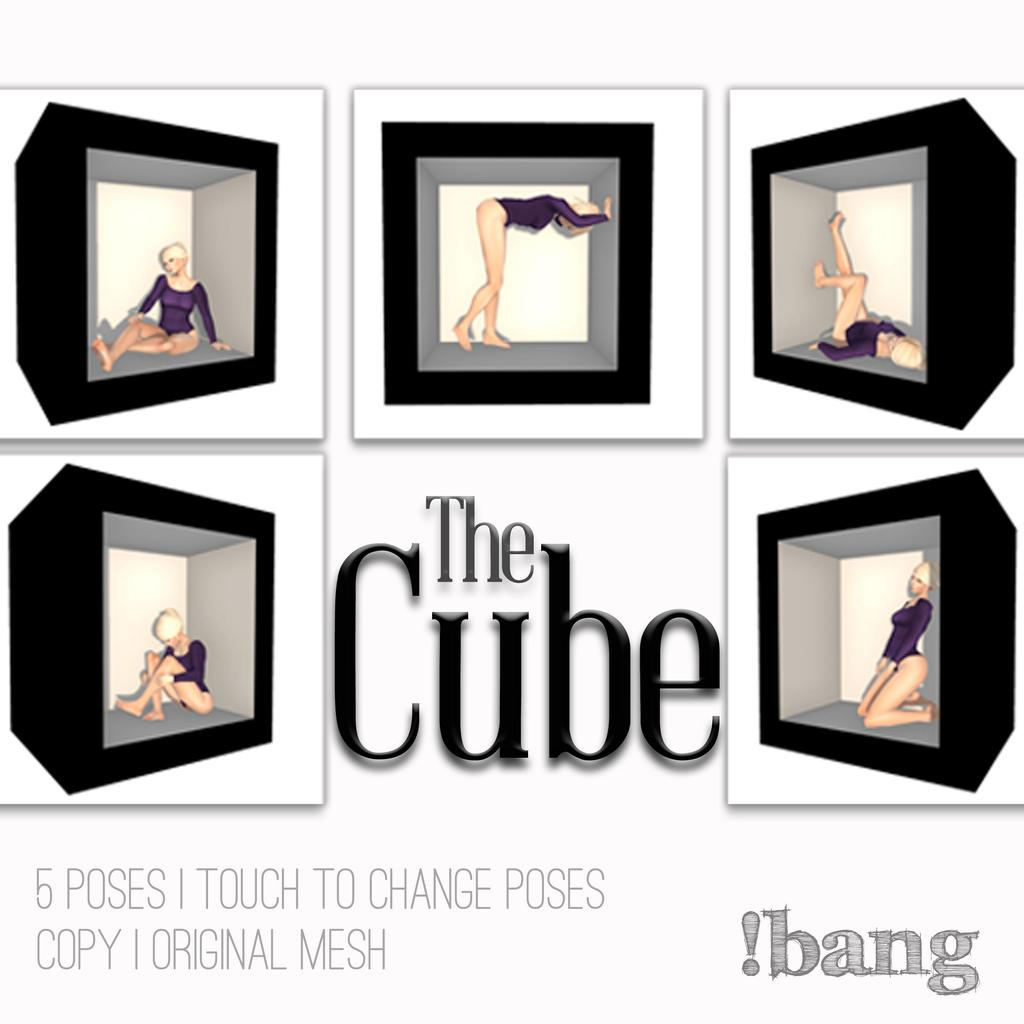<image>
Render a clear and concise summary of the photo. An advertisement called The Cube showing six cubes with a women inside showing stretches. 